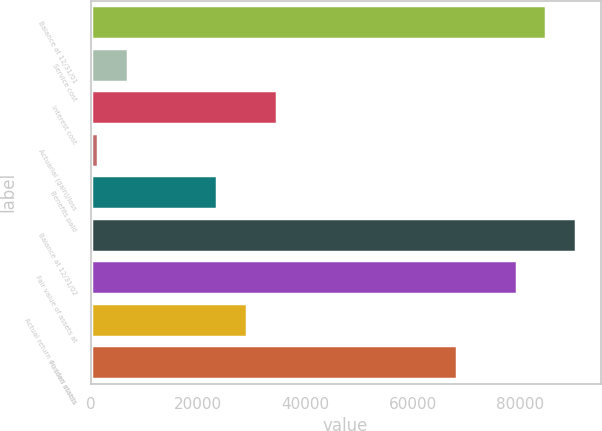<chart> <loc_0><loc_0><loc_500><loc_500><bar_chart><fcel>Balance at 12/31/01<fcel>Service cost<fcel>Interest cost<fcel>Actuarial (gain)/loss<fcel>Benefits paid<fcel>Balance at 12/31/02<fcel>Fair value of assets at<fcel>Actual return on plan assets<fcel>Funded status<nl><fcel>84957<fcel>6915.4<fcel>34787.4<fcel>1341<fcel>23638.6<fcel>90531.4<fcel>79382.6<fcel>29213<fcel>68233.8<nl></chart> 